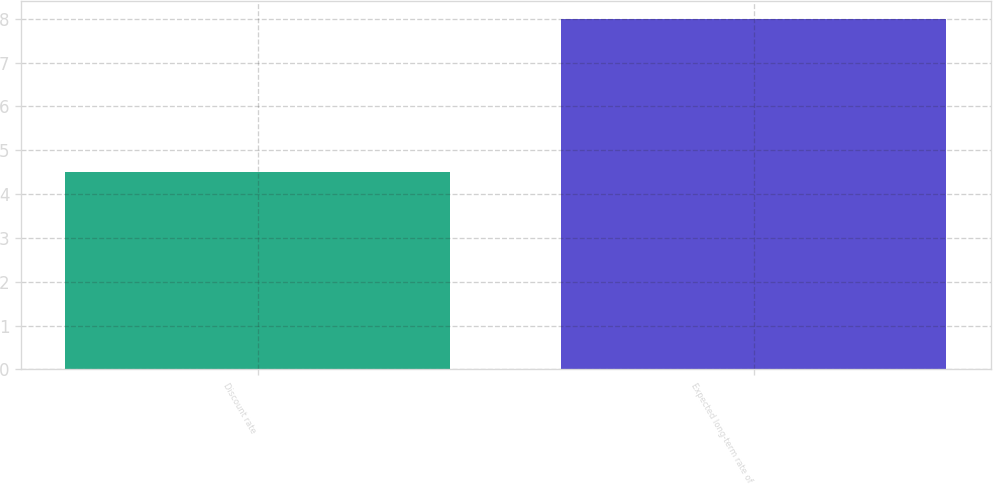Convert chart. <chart><loc_0><loc_0><loc_500><loc_500><bar_chart><fcel>Discount rate<fcel>Expected long-term rate of<nl><fcel>4.5<fcel>8<nl></chart> 